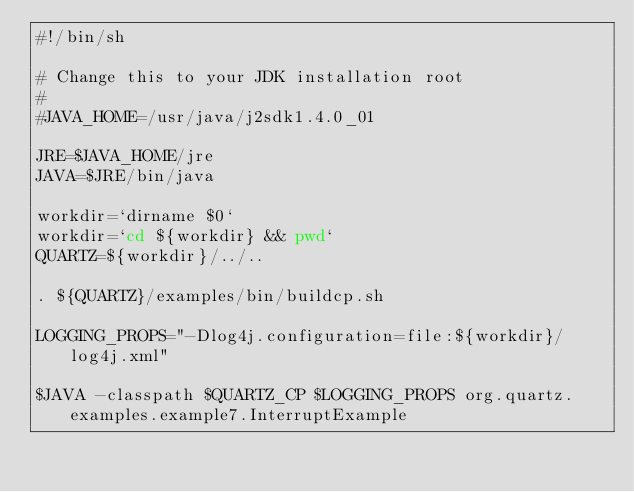<code> <loc_0><loc_0><loc_500><loc_500><_Bash_>#!/bin/sh

# Change this to your JDK installation root
#
#JAVA_HOME=/usr/java/j2sdk1.4.0_01

JRE=$JAVA_HOME/jre
JAVA=$JRE/bin/java

workdir=`dirname $0`
workdir=`cd ${workdir} && pwd`
QUARTZ=${workdir}/../..

. ${QUARTZ}/examples/bin/buildcp.sh

LOGGING_PROPS="-Dlog4j.configuration=file:${workdir}/log4j.xml"

$JAVA -classpath $QUARTZ_CP $LOGGING_PROPS org.quartz.examples.example7.InterruptExample

</code> 